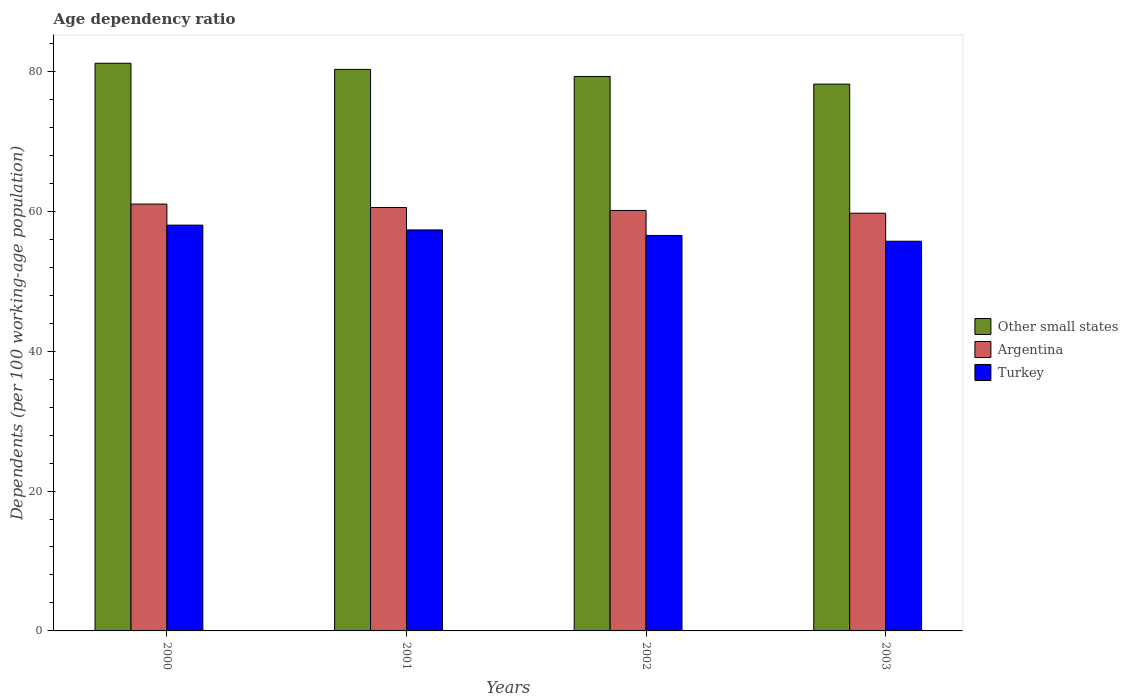How many bars are there on the 2nd tick from the right?
Your answer should be very brief. 3. What is the label of the 3rd group of bars from the left?
Offer a very short reply. 2002. In how many cases, is the number of bars for a given year not equal to the number of legend labels?
Offer a terse response. 0. What is the age dependency ratio in in Turkey in 2003?
Offer a very short reply. 55.71. Across all years, what is the maximum age dependency ratio in in Turkey?
Ensure brevity in your answer.  58.01. Across all years, what is the minimum age dependency ratio in in Argentina?
Offer a very short reply. 59.71. In which year was the age dependency ratio in in Turkey maximum?
Your answer should be very brief. 2000. What is the total age dependency ratio in in Argentina in the graph?
Your answer should be compact. 241.38. What is the difference between the age dependency ratio in in Other small states in 2002 and that in 2003?
Your answer should be very brief. 1.1. What is the difference between the age dependency ratio in in Turkey in 2000 and the age dependency ratio in in Argentina in 2003?
Provide a short and direct response. -1.7. What is the average age dependency ratio in in Turkey per year?
Keep it short and to the point. 56.9. In the year 2003, what is the difference between the age dependency ratio in in Turkey and age dependency ratio in in Other small states?
Give a very brief answer. -22.46. In how many years, is the age dependency ratio in in Other small states greater than 40 %?
Ensure brevity in your answer.  4. What is the ratio of the age dependency ratio in in Other small states in 2001 to that in 2003?
Offer a terse response. 1.03. Is the difference between the age dependency ratio in in Turkey in 2000 and 2003 greater than the difference between the age dependency ratio in in Other small states in 2000 and 2003?
Your answer should be compact. No. What is the difference between the highest and the second highest age dependency ratio in in Other small states?
Offer a terse response. 0.88. What is the difference between the highest and the lowest age dependency ratio in in Turkey?
Your response must be concise. 2.3. In how many years, is the age dependency ratio in in Other small states greater than the average age dependency ratio in in Other small states taken over all years?
Make the answer very short. 2. Is the sum of the age dependency ratio in in Argentina in 2001 and 2002 greater than the maximum age dependency ratio in in Turkey across all years?
Provide a succinct answer. Yes. What does the 1st bar from the right in 2003 represents?
Provide a succinct answer. Turkey. How many years are there in the graph?
Ensure brevity in your answer.  4. Are the values on the major ticks of Y-axis written in scientific E-notation?
Provide a succinct answer. No. Does the graph contain any zero values?
Your response must be concise. No. How many legend labels are there?
Offer a very short reply. 3. How are the legend labels stacked?
Keep it short and to the point. Vertical. What is the title of the graph?
Give a very brief answer. Age dependency ratio. Does "Morocco" appear as one of the legend labels in the graph?
Give a very brief answer. No. What is the label or title of the Y-axis?
Give a very brief answer. Dependents (per 100 working-age population). What is the Dependents (per 100 working-age population) in Other small states in 2000?
Provide a short and direct response. 81.15. What is the Dependents (per 100 working-age population) in Argentina in 2000?
Give a very brief answer. 61.02. What is the Dependents (per 100 working-age population) in Turkey in 2000?
Your answer should be compact. 58.01. What is the Dependents (per 100 working-age population) in Other small states in 2001?
Your answer should be compact. 80.27. What is the Dependents (per 100 working-age population) in Argentina in 2001?
Provide a succinct answer. 60.53. What is the Dependents (per 100 working-age population) in Turkey in 2001?
Offer a terse response. 57.33. What is the Dependents (per 100 working-age population) of Other small states in 2002?
Offer a very short reply. 79.26. What is the Dependents (per 100 working-age population) in Argentina in 2002?
Your response must be concise. 60.11. What is the Dependents (per 100 working-age population) in Turkey in 2002?
Provide a succinct answer. 56.53. What is the Dependents (per 100 working-age population) in Other small states in 2003?
Keep it short and to the point. 78.17. What is the Dependents (per 100 working-age population) of Argentina in 2003?
Provide a short and direct response. 59.71. What is the Dependents (per 100 working-age population) in Turkey in 2003?
Offer a very short reply. 55.71. Across all years, what is the maximum Dependents (per 100 working-age population) of Other small states?
Keep it short and to the point. 81.15. Across all years, what is the maximum Dependents (per 100 working-age population) of Argentina?
Offer a terse response. 61.02. Across all years, what is the maximum Dependents (per 100 working-age population) in Turkey?
Provide a succinct answer. 58.01. Across all years, what is the minimum Dependents (per 100 working-age population) of Other small states?
Keep it short and to the point. 78.17. Across all years, what is the minimum Dependents (per 100 working-age population) in Argentina?
Your answer should be very brief. 59.71. Across all years, what is the minimum Dependents (per 100 working-age population) of Turkey?
Provide a short and direct response. 55.71. What is the total Dependents (per 100 working-age population) in Other small states in the graph?
Offer a very short reply. 318.86. What is the total Dependents (per 100 working-age population) in Argentina in the graph?
Ensure brevity in your answer.  241.38. What is the total Dependents (per 100 working-age population) of Turkey in the graph?
Ensure brevity in your answer.  227.58. What is the difference between the Dependents (per 100 working-age population) in Other small states in 2000 and that in 2001?
Keep it short and to the point. 0.88. What is the difference between the Dependents (per 100 working-age population) in Argentina in 2000 and that in 2001?
Your answer should be very brief. 0.49. What is the difference between the Dependents (per 100 working-age population) in Turkey in 2000 and that in 2001?
Offer a terse response. 0.68. What is the difference between the Dependents (per 100 working-age population) of Other small states in 2000 and that in 2002?
Provide a succinct answer. 1.89. What is the difference between the Dependents (per 100 working-age population) in Argentina in 2000 and that in 2002?
Offer a very short reply. 0.91. What is the difference between the Dependents (per 100 working-age population) of Turkey in 2000 and that in 2002?
Offer a very short reply. 1.48. What is the difference between the Dependents (per 100 working-age population) of Other small states in 2000 and that in 2003?
Give a very brief answer. 2.98. What is the difference between the Dependents (per 100 working-age population) of Argentina in 2000 and that in 2003?
Your response must be concise. 1.31. What is the difference between the Dependents (per 100 working-age population) in Turkey in 2000 and that in 2003?
Your response must be concise. 2.3. What is the difference between the Dependents (per 100 working-age population) of Other small states in 2001 and that in 2002?
Keep it short and to the point. 1.01. What is the difference between the Dependents (per 100 working-age population) in Argentina in 2001 and that in 2002?
Offer a very short reply. 0.42. What is the difference between the Dependents (per 100 working-age population) in Turkey in 2001 and that in 2002?
Ensure brevity in your answer.  0.79. What is the difference between the Dependents (per 100 working-age population) in Other small states in 2001 and that in 2003?
Offer a terse response. 2.1. What is the difference between the Dependents (per 100 working-age population) of Argentina in 2001 and that in 2003?
Your answer should be very brief. 0.82. What is the difference between the Dependents (per 100 working-age population) of Turkey in 2001 and that in 2003?
Offer a terse response. 1.62. What is the difference between the Dependents (per 100 working-age population) in Other small states in 2002 and that in 2003?
Your response must be concise. 1.1. What is the difference between the Dependents (per 100 working-age population) in Argentina in 2002 and that in 2003?
Your answer should be compact. 0.4. What is the difference between the Dependents (per 100 working-age population) in Turkey in 2002 and that in 2003?
Offer a terse response. 0.82. What is the difference between the Dependents (per 100 working-age population) in Other small states in 2000 and the Dependents (per 100 working-age population) in Argentina in 2001?
Give a very brief answer. 20.62. What is the difference between the Dependents (per 100 working-age population) in Other small states in 2000 and the Dependents (per 100 working-age population) in Turkey in 2001?
Your answer should be compact. 23.82. What is the difference between the Dependents (per 100 working-age population) in Argentina in 2000 and the Dependents (per 100 working-age population) in Turkey in 2001?
Provide a short and direct response. 3.69. What is the difference between the Dependents (per 100 working-age population) in Other small states in 2000 and the Dependents (per 100 working-age population) in Argentina in 2002?
Give a very brief answer. 21.04. What is the difference between the Dependents (per 100 working-age population) in Other small states in 2000 and the Dependents (per 100 working-age population) in Turkey in 2002?
Your answer should be compact. 24.62. What is the difference between the Dependents (per 100 working-age population) in Argentina in 2000 and the Dependents (per 100 working-age population) in Turkey in 2002?
Keep it short and to the point. 4.49. What is the difference between the Dependents (per 100 working-age population) of Other small states in 2000 and the Dependents (per 100 working-age population) of Argentina in 2003?
Make the answer very short. 21.44. What is the difference between the Dependents (per 100 working-age population) of Other small states in 2000 and the Dependents (per 100 working-age population) of Turkey in 2003?
Offer a terse response. 25.44. What is the difference between the Dependents (per 100 working-age population) in Argentina in 2000 and the Dependents (per 100 working-age population) in Turkey in 2003?
Provide a succinct answer. 5.31. What is the difference between the Dependents (per 100 working-age population) of Other small states in 2001 and the Dependents (per 100 working-age population) of Argentina in 2002?
Give a very brief answer. 20.16. What is the difference between the Dependents (per 100 working-age population) of Other small states in 2001 and the Dependents (per 100 working-age population) of Turkey in 2002?
Provide a succinct answer. 23.74. What is the difference between the Dependents (per 100 working-age population) of Argentina in 2001 and the Dependents (per 100 working-age population) of Turkey in 2002?
Keep it short and to the point. 4. What is the difference between the Dependents (per 100 working-age population) in Other small states in 2001 and the Dependents (per 100 working-age population) in Argentina in 2003?
Your answer should be very brief. 20.56. What is the difference between the Dependents (per 100 working-age population) of Other small states in 2001 and the Dependents (per 100 working-age population) of Turkey in 2003?
Ensure brevity in your answer.  24.56. What is the difference between the Dependents (per 100 working-age population) in Argentina in 2001 and the Dependents (per 100 working-age population) in Turkey in 2003?
Ensure brevity in your answer.  4.82. What is the difference between the Dependents (per 100 working-age population) in Other small states in 2002 and the Dependents (per 100 working-age population) in Argentina in 2003?
Make the answer very short. 19.55. What is the difference between the Dependents (per 100 working-age population) of Other small states in 2002 and the Dependents (per 100 working-age population) of Turkey in 2003?
Give a very brief answer. 23.55. What is the difference between the Dependents (per 100 working-age population) in Argentina in 2002 and the Dependents (per 100 working-age population) in Turkey in 2003?
Give a very brief answer. 4.4. What is the average Dependents (per 100 working-age population) in Other small states per year?
Ensure brevity in your answer.  79.71. What is the average Dependents (per 100 working-age population) of Argentina per year?
Offer a terse response. 60.34. What is the average Dependents (per 100 working-age population) of Turkey per year?
Your response must be concise. 56.9. In the year 2000, what is the difference between the Dependents (per 100 working-age population) of Other small states and Dependents (per 100 working-age population) of Argentina?
Keep it short and to the point. 20.13. In the year 2000, what is the difference between the Dependents (per 100 working-age population) in Other small states and Dependents (per 100 working-age population) in Turkey?
Offer a very short reply. 23.14. In the year 2000, what is the difference between the Dependents (per 100 working-age population) of Argentina and Dependents (per 100 working-age population) of Turkey?
Provide a short and direct response. 3.01. In the year 2001, what is the difference between the Dependents (per 100 working-age population) of Other small states and Dependents (per 100 working-age population) of Argentina?
Ensure brevity in your answer.  19.74. In the year 2001, what is the difference between the Dependents (per 100 working-age population) of Other small states and Dependents (per 100 working-age population) of Turkey?
Make the answer very short. 22.95. In the year 2001, what is the difference between the Dependents (per 100 working-age population) of Argentina and Dependents (per 100 working-age population) of Turkey?
Provide a short and direct response. 3.2. In the year 2002, what is the difference between the Dependents (per 100 working-age population) in Other small states and Dependents (per 100 working-age population) in Argentina?
Make the answer very short. 19.15. In the year 2002, what is the difference between the Dependents (per 100 working-age population) in Other small states and Dependents (per 100 working-age population) in Turkey?
Keep it short and to the point. 22.73. In the year 2002, what is the difference between the Dependents (per 100 working-age population) of Argentina and Dependents (per 100 working-age population) of Turkey?
Provide a succinct answer. 3.58. In the year 2003, what is the difference between the Dependents (per 100 working-age population) in Other small states and Dependents (per 100 working-age population) in Argentina?
Offer a very short reply. 18.45. In the year 2003, what is the difference between the Dependents (per 100 working-age population) in Other small states and Dependents (per 100 working-age population) in Turkey?
Offer a terse response. 22.46. In the year 2003, what is the difference between the Dependents (per 100 working-age population) of Argentina and Dependents (per 100 working-age population) of Turkey?
Ensure brevity in your answer.  4. What is the ratio of the Dependents (per 100 working-age population) of Other small states in 2000 to that in 2001?
Offer a very short reply. 1.01. What is the ratio of the Dependents (per 100 working-age population) in Argentina in 2000 to that in 2001?
Offer a very short reply. 1.01. What is the ratio of the Dependents (per 100 working-age population) in Turkey in 2000 to that in 2001?
Ensure brevity in your answer.  1.01. What is the ratio of the Dependents (per 100 working-age population) of Other small states in 2000 to that in 2002?
Ensure brevity in your answer.  1.02. What is the ratio of the Dependents (per 100 working-age population) of Argentina in 2000 to that in 2002?
Your answer should be very brief. 1.02. What is the ratio of the Dependents (per 100 working-age population) of Turkey in 2000 to that in 2002?
Give a very brief answer. 1.03. What is the ratio of the Dependents (per 100 working-age population) in Other small states in 2000 to that in 2003?
Ensure brevity in your answer.  1.04. What is the ratio of the Dependents (per 100 working-age population) of Argentina in 2000 to that in 2003?
Provide a short and direct response. 1.02. What is the ratio of the Dependents (per 100 working-age population) of Turkey in 2000 to that in 2003?
Give a very brief answer. 1.04. What is the ratio of the Dependents (per 100 working-age population) in Other small states in 2001 to that in 2002?
Your response must be concise. 1.01. What is the ratio of the Dependents (per 100 working-age population) in Argentina in 2001 to that in 2002?
Your response must be concise. 1.01. What is the ratio of the Dependents (per 100 working-age population) of Turkey in 2001 to that in 2002?
Your answer should be very brief. 1.01. What is the ratio of the Dependents (per 100 working-age population) in Other small states in 2001 to that in 2003?
Offer a terse response. 1.03. What is the ratio of the Dependents (per 100 working-age population) of Argentina in 2001 to that in 2003?
Make the answer very short. 1.01. What is the ratio of the Dependents (per 100 working-age population) of Argentina in 2002 to that in 2003?
Offer a terse response. 1.01. What is the ratio of the Dependents (per 100 working-age population) in Turkey in 2002 to that in 2003?
Give a very brief answer. 1.01. What is the difference between the highest and the second highest Dependents (per 100 working-age population) of Other small states?
Keep it short and to the point. 0.88. What is the difference between the highest and the second highest Dependents (per 100 working-age population) of Argentina?
Provide a short and direct response. 0.49. What is the difference between the highest and the second highest Dependents (per 100 working-age population) in Turkey?
Provide a short and direct response. 0.68. What is the difference between the highest and the lowest Dependents (per 100 working-age population) in Other small states?
Your response must be concise. 2.98. What is the difference between the highest and the lowest Dependents (per 100 working-age population) of Argentina?
Your answer should be compact. 1.31. What is the difference between the highest and the lowest Dependents (per 100 working-age population) of Turkey?
Give a very brief answer. 2.3. 